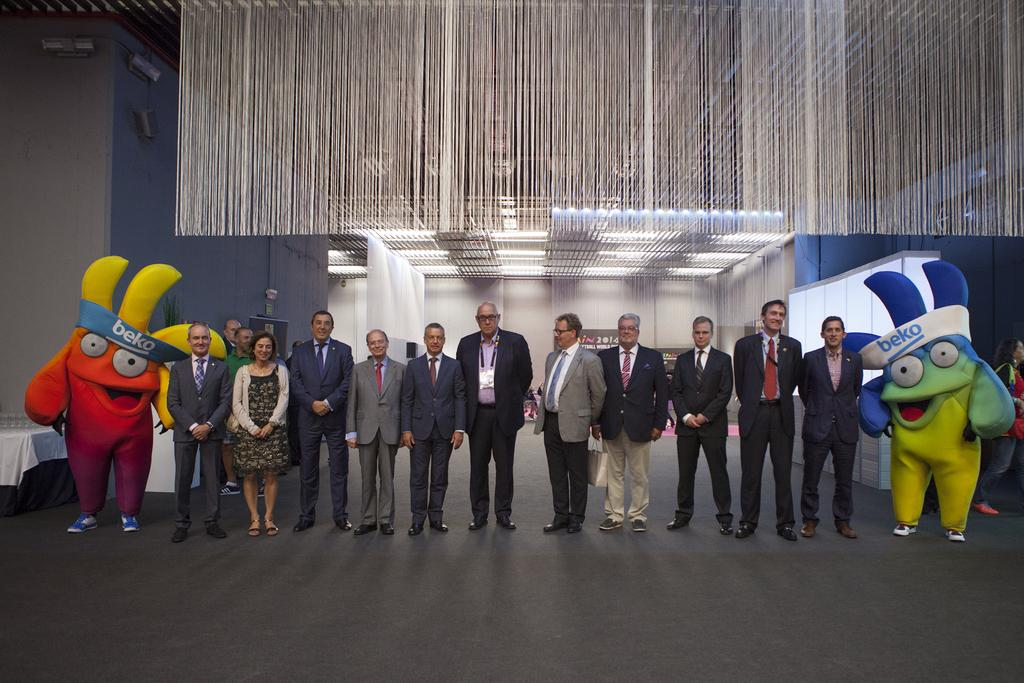Who is present in the image? There are people and clowns in the image. What are the people and clowns doing in the image? They are standing on the floor. What can be seen in the background of the image? There are grills, electric lights, and tables in the background. What type of camp can be seen in the background of the image? There is no camp present in the image; it features people, clowns, and various objects in the foreground and background. What type of fork is being used by the clowns in the image? There is no fork visible in the image; only people, clowns, and various objects are present. 